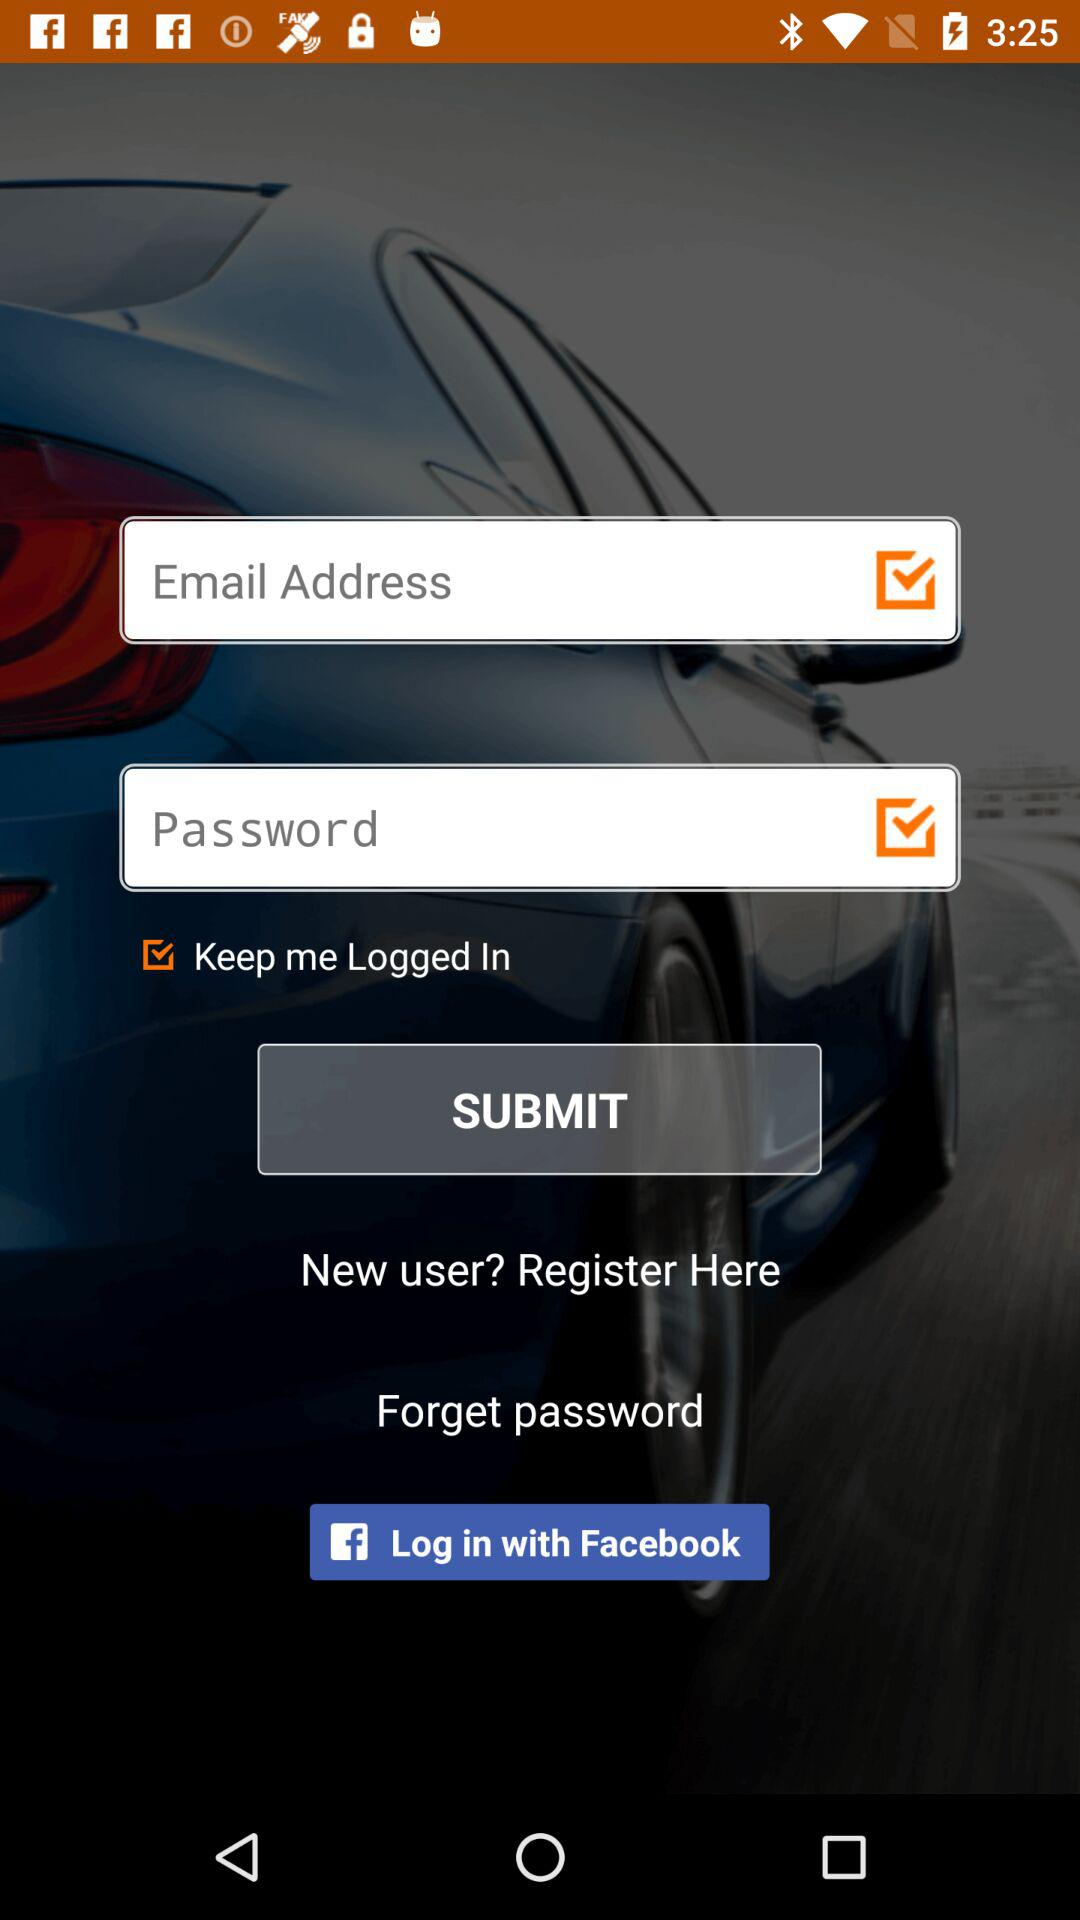What are the options available for logging in? There are two logging-in options available: "Email address" and "Facebook". 